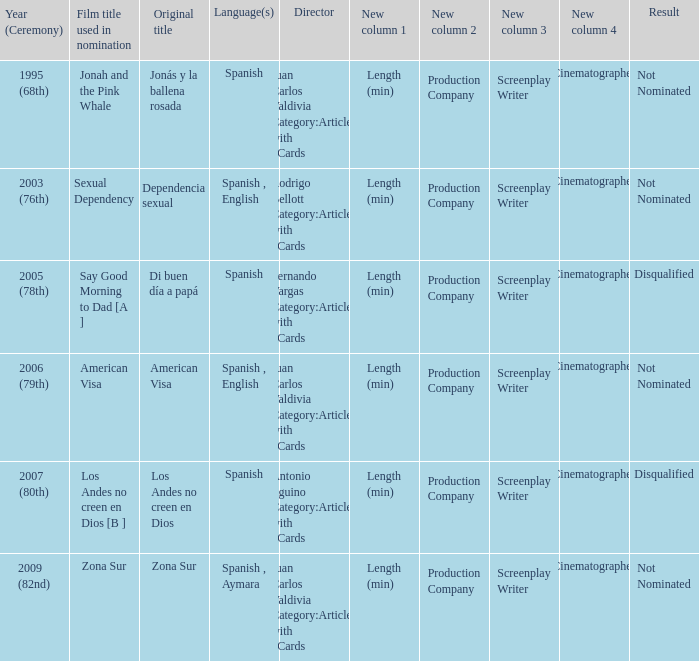What was Zona Sur's result after being considered for nomination? Not Nominated. 